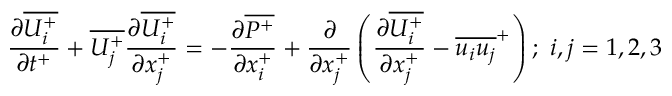<formula> <loc_0><loc_0><loc_500><loc_500>{ \frac { \partial \overline { { U _ { i } ^ { + } } } } { \partial t ^ { + } } } + \overline { { U _ { j } ^ { + } } } \frac { \partial \overline { { U _ { i } ^ { + } } } } { \partial x _ { j } ^ { + } } = - \frac { \partial \overline { { P ^ { + } } } } { \partial x _ { i } ^ { + } } + \frac { \partial } { \partial x _ { j } ^ { + } } \left ( \frac { \partial \overline { { U _ { i } ^ { + } } } } { \partial x _ { j } ^ { + } } - \overline { { u _ { i } u _ { j } } } ^ { + } \right ) ; i , j = { 1 , 2 , 3 }</formula> 